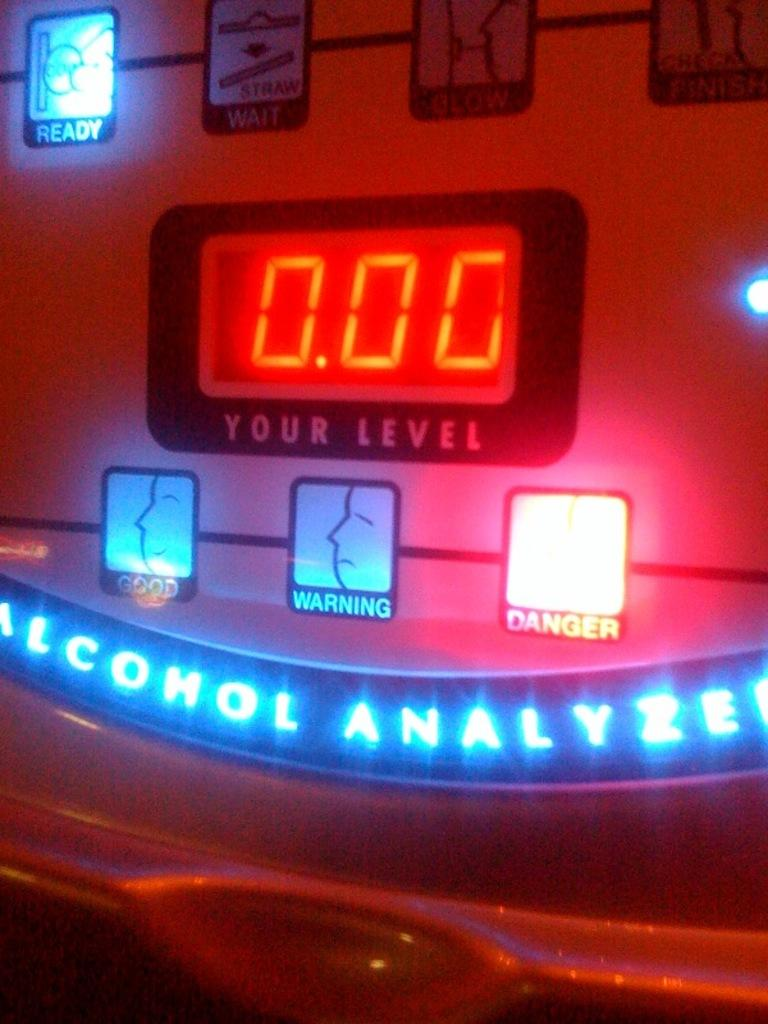<image>
Relay a brief, clear account of the picture shown. The screen of an Alcohol Analyzer that shows your level. 